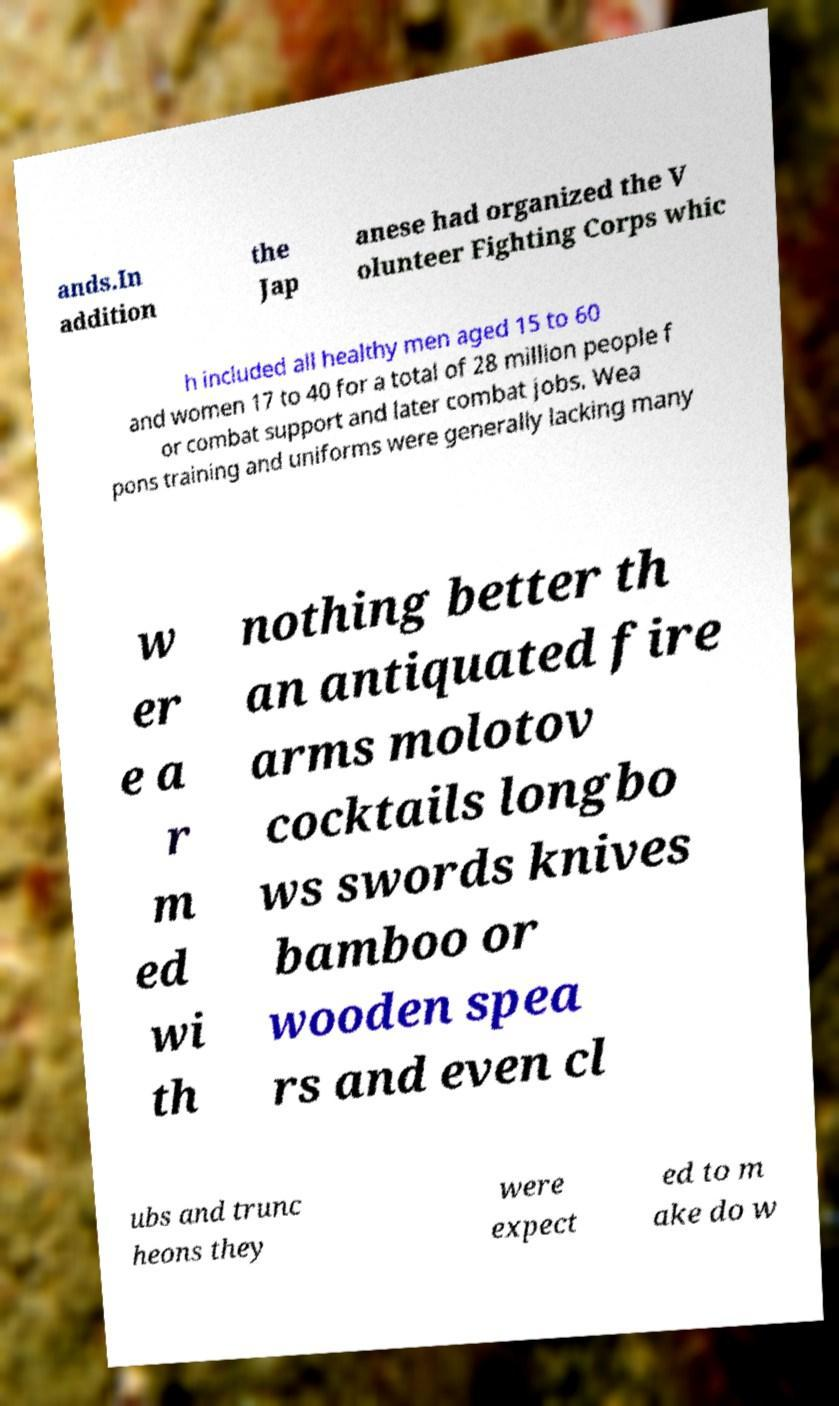There's text embedded in this image that I need extracted. Can you transcribe it verbatim? ands.In addition the Jap anese had organized the V olunteer Fighting Corps whic h included all healthy men aged 15 to 60 and women 17 to 40 for a total of 28 million people f or combat support and later combat jobs. Wea pons training and uniforms were generally lacking many w er e a r m ed wi th nothing better th an antiquated fire arms molotov cocktails longbo ws swords knives bamboo or wooden spea rs and even cl ubs and trunc heons they were expect ed to m ake do w 